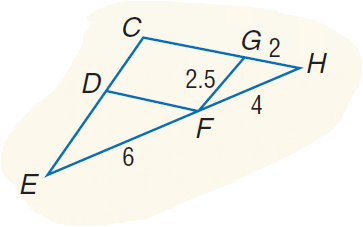Answer the mathemtical geometry problem and directly provide the correct option letter.
Question: Find the perimeter of \triangle D E F if \triangle D E F \sim \triangle G F H.
Choices: A: 12 B: 12.25 C: 12.5 D: 12.75 D 